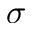<formula> <loc_0><loc_0><loc_500><loc_500>\sigma</formula> 